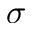<formula> <loc_0><loc_0><loc_500><loc_500>\sigma</formula> 